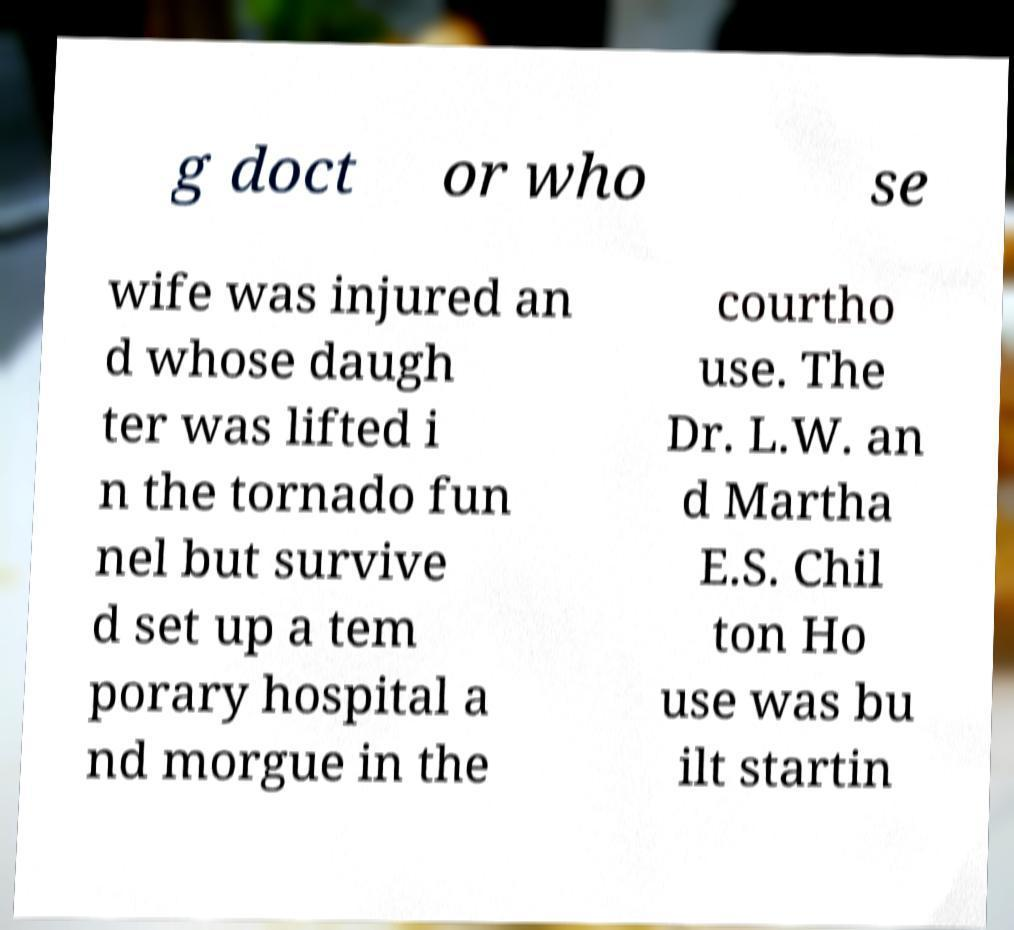I need the written content from this picture converted into text. Can you do that? g doct or who se wife was injured an d whose daugh ter was lifted i n the tornado fun nel but survive d set up a tem porary hospital a nd morgue in the courtho use. The Dr. L.W. an d Martha E.S. Chil ton Ho use was bu ilt startin 